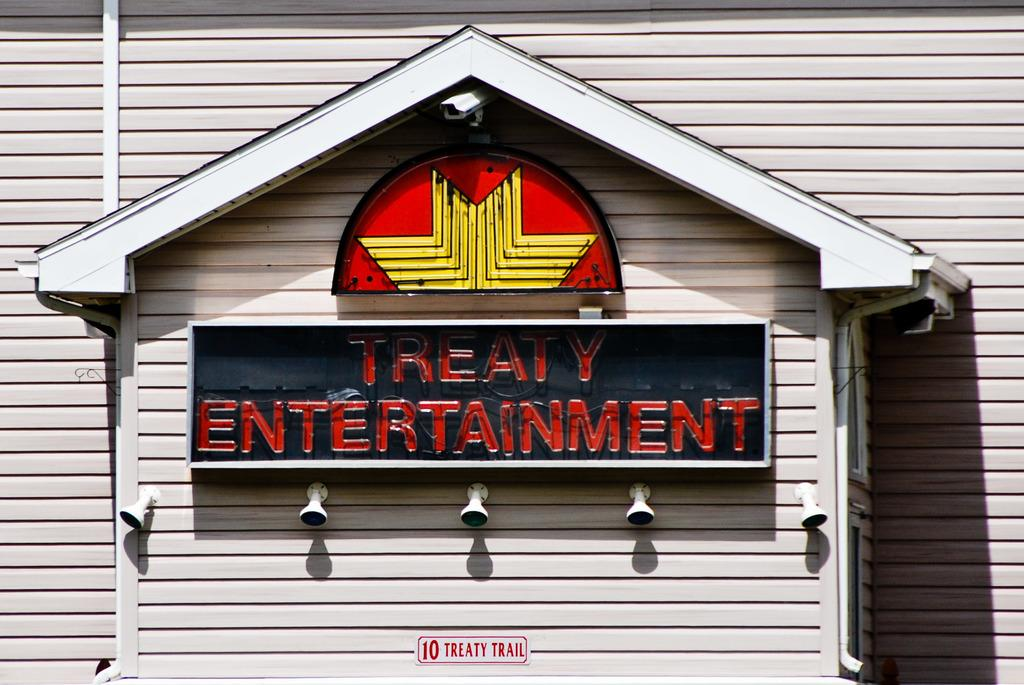What type of structure is present in the image? There is a house in the image. Can you describe the color of the house? The house is white. What other objects are attached to the house? There is a black color board attached to the house. Are there any other boards visible in the image? Yes, there is another board in yellow and red colors. What song is being played in the background of the image? There is no information about any song being played in the image. 